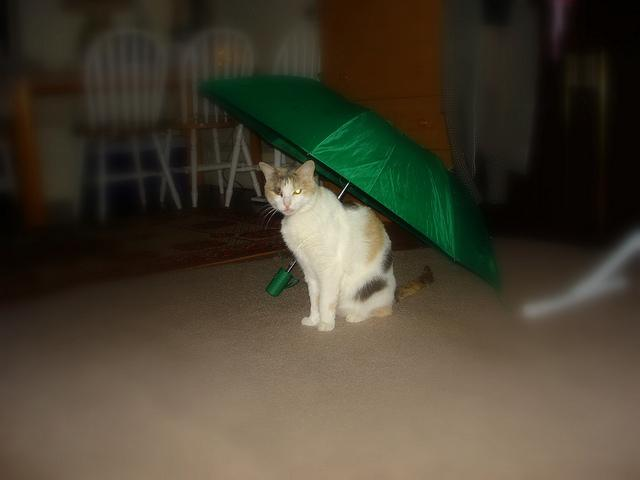What is the white object to the right of the cat likely to be?

Choices:
A) bicycle
B) ironing board
C) table
D) toy ironing board 